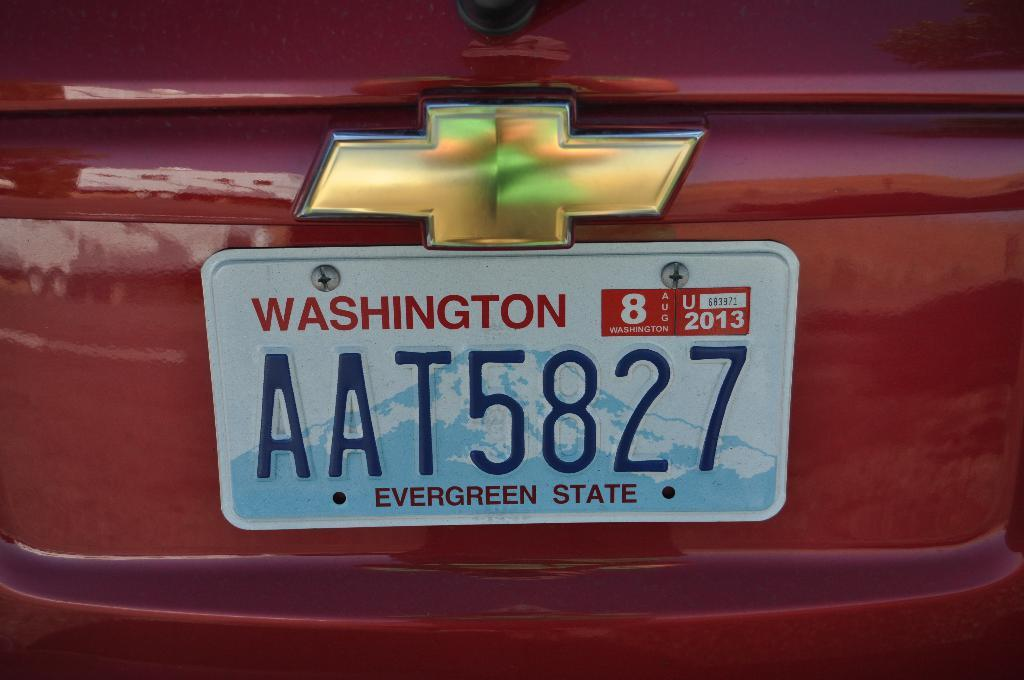<image>
Provide a brief description of the given image. A Washington state license plate on a red Chevy reads AAT5827. 